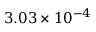<formula> <loc_0><loc_0><loc_500><loc_500>3 . 0 3 \times 1 0 ^ { - 4 }</formula> 